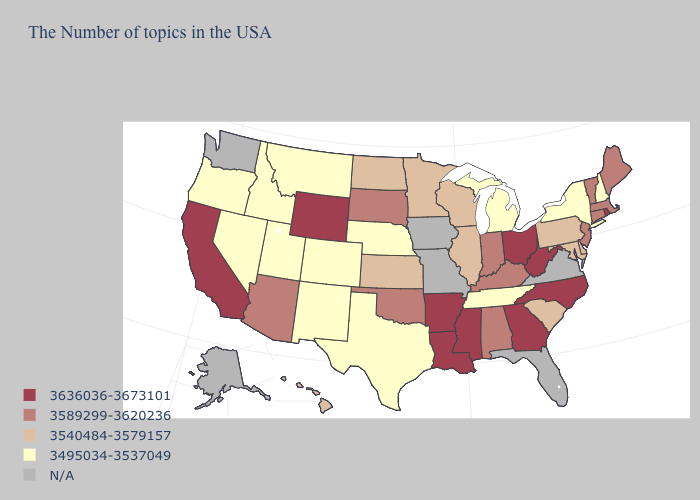Which states have the lowest value in the USA?
Concise answer only. New Hampshire, New York, Michigan, Tennessee, Nebraska, Texas, Colorado, New Mexico, Utah, Montana, Idaho, Nevada, Oregon. Name the states that have a value in the range 3540484-3579157?
Answer briefly. Delaware, Maryland, Pennsylvania, South Carolina, Wisconsin, Illinois, Minnesota, Kansas, North Dakota, Hawaii. What is the lowest value in the USA?
Quick response, please. 3495034-3537049. Name the states that have a value in the range 3636036-3673101?
Keep it brief. Rhode Island, North Carolina, West Virginia, Ohio, Georgia, Mississippi, Louisiana, Arkansas, Wyoming, California. What is the value of Maine?
Short answer required. 3589299-3620236. What is the value of Oklahoma?
Keep it brief. 3589299-3620236. What is the value of Kentucky?
Quick response, please. 3589299-3620236. Does the map have missing data?
Answer briefly. Yes. What is the value of Louisiana?
Quick response, please. 3636036-3673101. What is the lowest value in the USA?
Concise answer only. 3495034-3537049. Name the states that have a value in the range N/A?
Keep it brief. Virginia, Florida, Missouri, Iowa, Washington, Alaska. What is the value of Iowa?
Keep it brief. N/A. Among the states that border Wyoming , does Montana have the lowest value?
Keep it brief. Yes. 